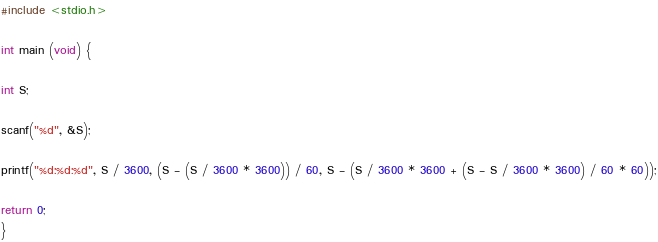<code> <loc_0><loc_0><loc_500><loc_500><_C_>#include <stdio.h>

int main (void) {

int S;

scanf("%d", &S);

printf("%d:%d:%d", S / 3600, (S - (S / 3600 * 3600)) / 60, S - (S / 3600 * 3600 + (S - S / 3600 * 3600) / 60 * 60));

return 0;
}</code> 